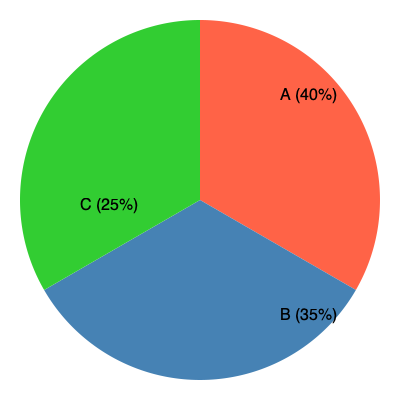Based on the pie chart representing Native American DNA haplogroups, which haplogroup is most prevalent, and what percentage does it represent? To determine the most prevalent haplogroup and its percentage, we need to analyze the pie chart:

1. The pie chart is divided into three sections, each representing a different haplogroup (A, B, and C).

2. Each section is labeled with a percentage:
   - Haplogroup A: 40%
   - Haplogroup B: 35%
   - Haplogroup C: 25%

3. Compare the percentages:
   40% > 35% > 25%

4. The largest percentage corresponds to the most prevalent haplogroup.

5. Haplogroup A has the largest percentage at 40%.

Therefore, Haplogroup A is the most prevalent, representing 40% of the Native American DNA haplogroups in this sample.
Answer: Haplogroup A, 40% 